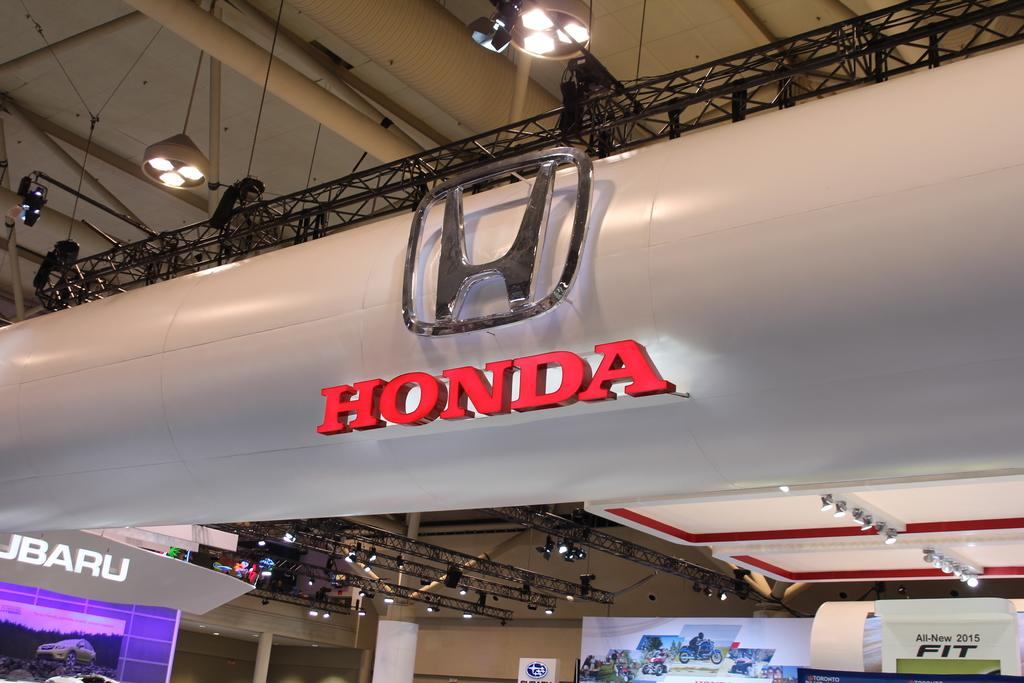<image>
Create a compact narrative representing the image presented. The Honda car logo hangs above a show room in a car dealership. 